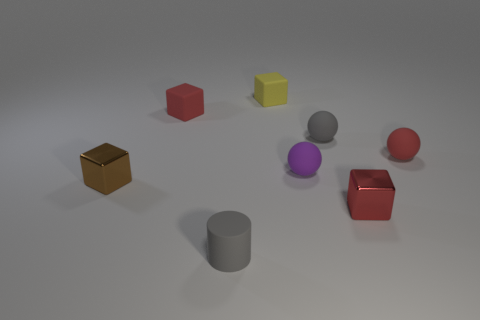What is the size of the red rubber object that is on the right side of the metal cube in front of the brown block?
Keep it short and to the point. Small. Are there more big yellow spheres than cylinders?
Ensure brevity in your answer.  No. There is a gray thing that is right of the purple ball; does it have the same size as the brown cube?
Your answer should be compact. Yes. What number of small balls are the same color as the tiny cylinder?
Your answer should be compact. 1. Is the tiny red metallic thing the same shape as the brown metal object?
Make the answer very short. Yes. What is the size of the other rubber thing that is the same shape as the small yellow matte thing?
Offer a terse response. Small. Are there more red matte objects that are behind the matte cylinder than small gray rubber balls in front of the small yellow rubber object?
Your response must be concise. Yes. Is the material of the small yellow block the same as the small red block left of the small red shiny thing?
Your answer should be very brief. Yes. There is a block that is both left of the tiny gray rubber ball and on the right side of the gray rubber cylinder; what color is it?
Ensure brevity in your answer.  Yellow. The gray thing to the right of the yellow matte thing has what shape?
Provide a short and direct response. Sphere. 